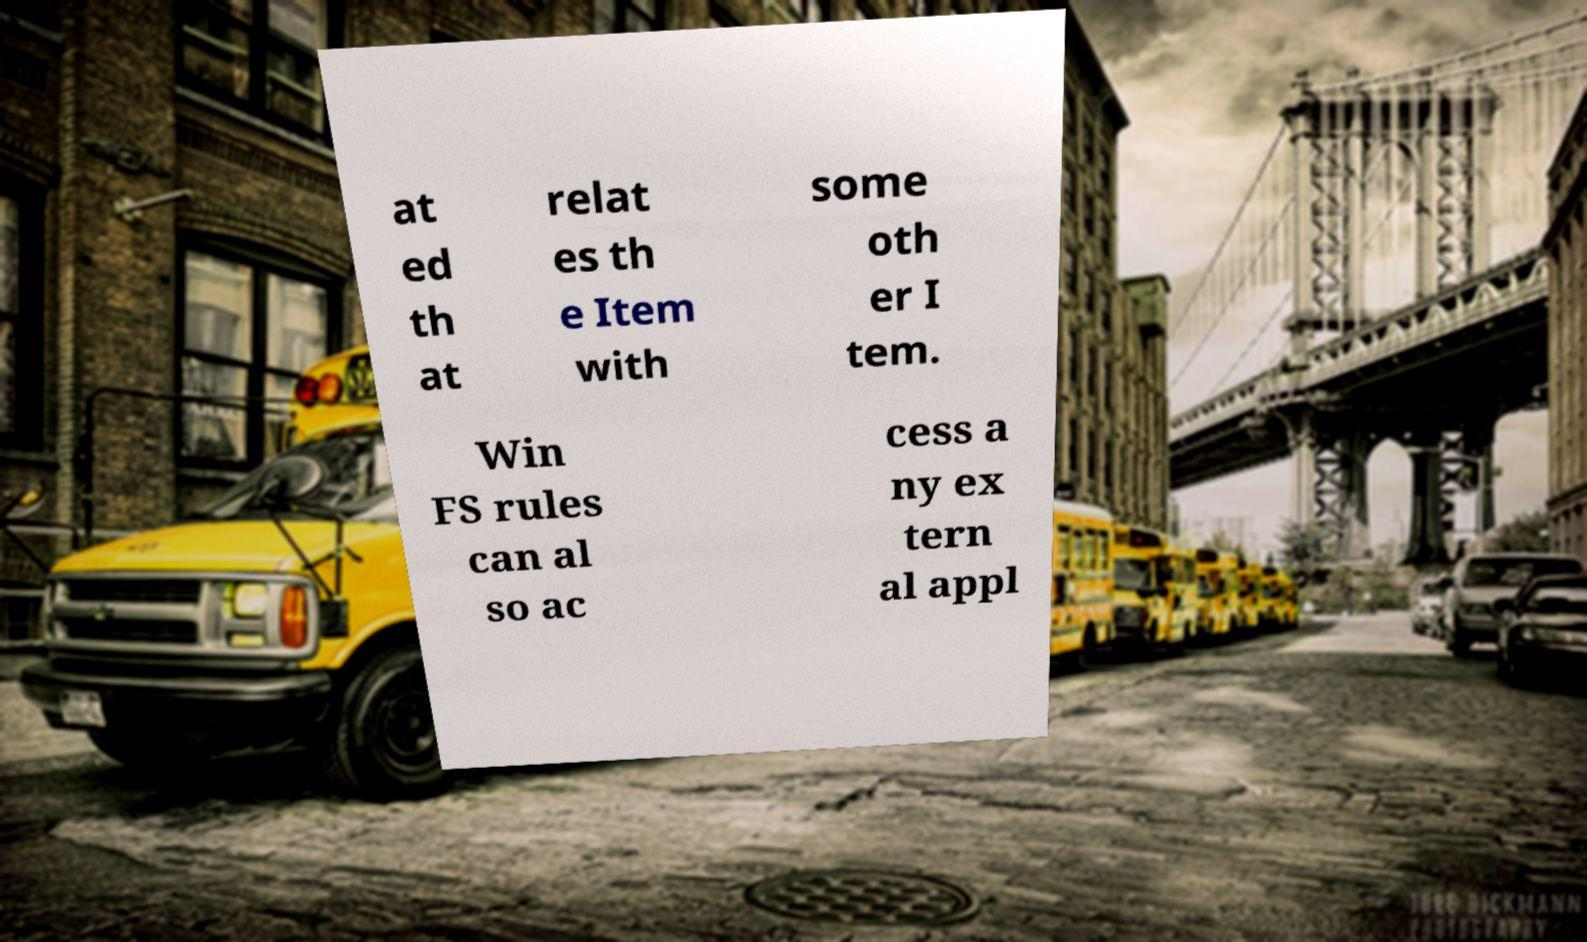I need the written content from this picture converted into text. Can you do that? at ed th at relat es th e Item with some oth er I tem. Win FS rules can al so ac cess a ny ex tern al appl 